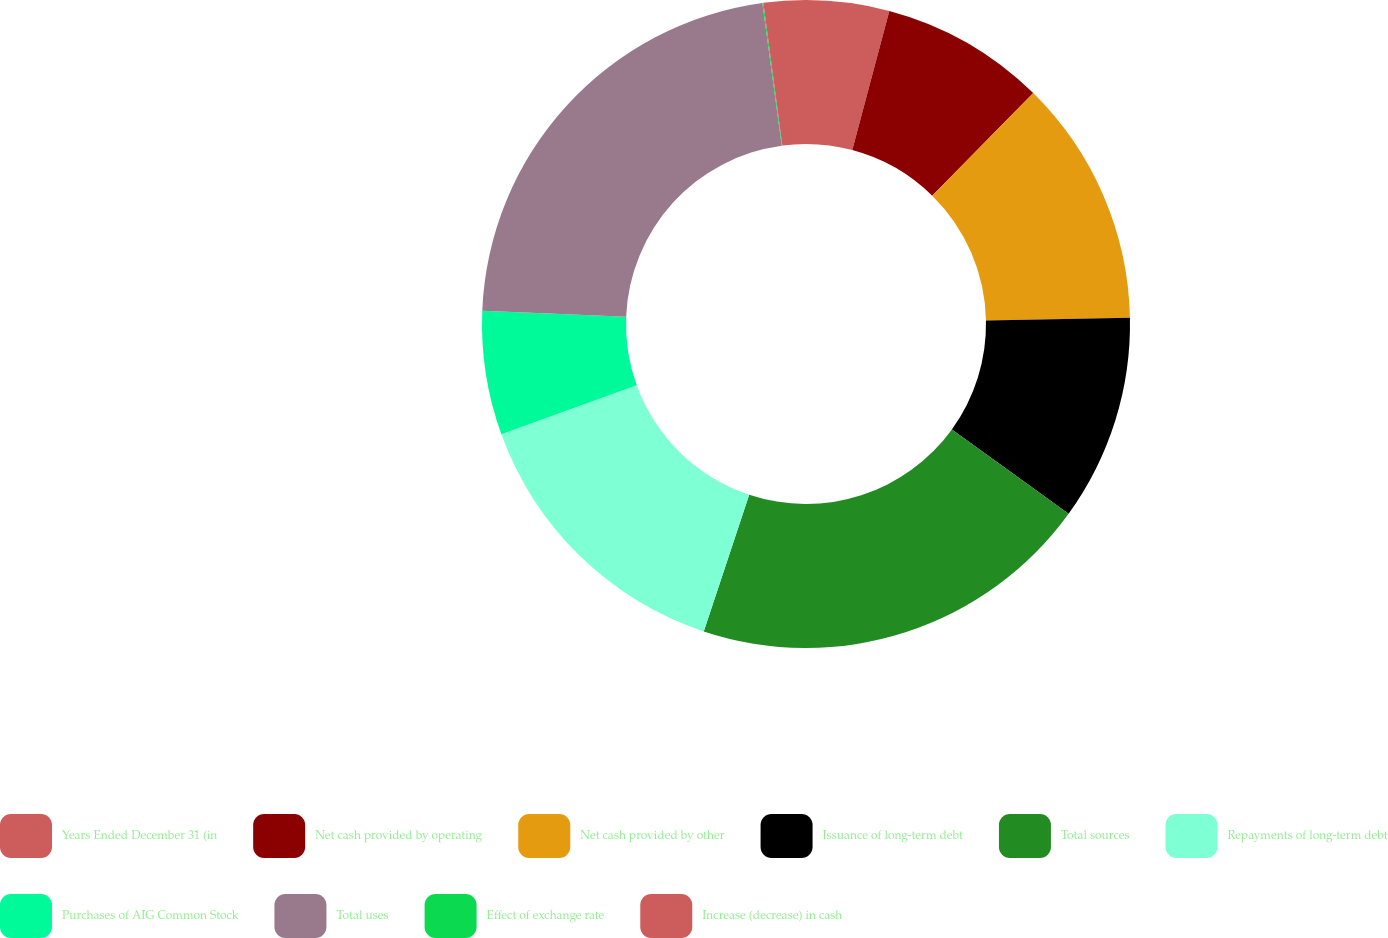Convert chart to OTSL. <chart><loc_0><loc_0><loc_500><loc_500><pie_chart><fcel>Years Ended December 31 (in<fcel>Net cash provided by operating<fcel>Net cash provided by other<fcel>Issuance of long-term debt<fcel>Total sources<fcel>Repayments of long-term debt<fcel>Purchases of AIG Common Stock<fcel>Total uses<fcel>Effect of exchange rate<fcel>Increase (decrease) in cash<nl><fcel>4.14%<fcel>8.23%<fcel>12.32%<fcel>10.27%<fcel>20.15%<fcel>14.36%<fcel>6.18%<fcel>22.2%<fcel>0.05%<fcel>2.1%<nl></chart> 